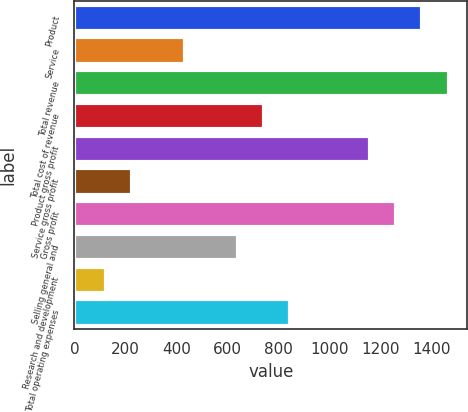<chart> <loc_0><loc_0><loc_500><loc_500><bar_chart><fcel>Product<fcel>Service<fcel>Total revenue<fcel>Total cost of revenue<fcel>Product gross profit<fcel>Service gross profit<fcel>Gross profit<fcel>Selling general and<fcel>Research and development<fcel>Total operating expenses<nl><fcel>1362.25<fcel>432.1<fcel>1465.6<fcel>742.15<fcel>1155.55<fcel>225.4<fcel>1258.9<fcel>638.8<fcel>122.05<fcel>845.5<nl></chart> 